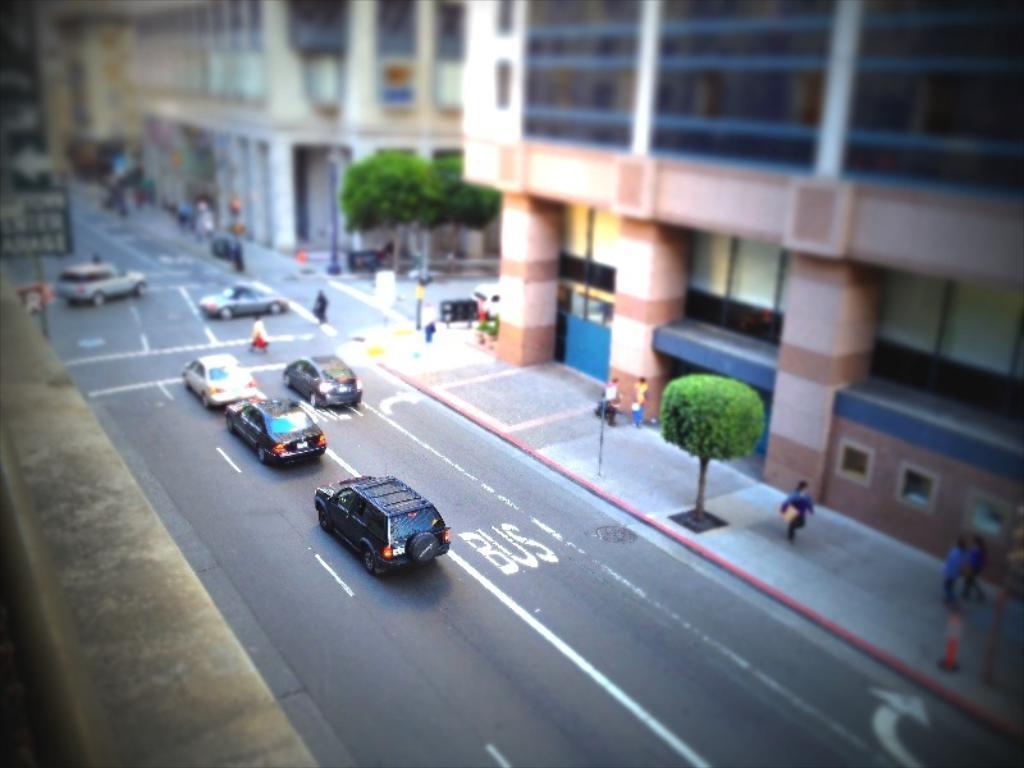Can you describe this image briefly? This image is the top view from which we can see the wall, vehicles moving on the road, people walking on the sidewalk, trees, buildings, boards and the poles. Here the image is slightly blurred. 